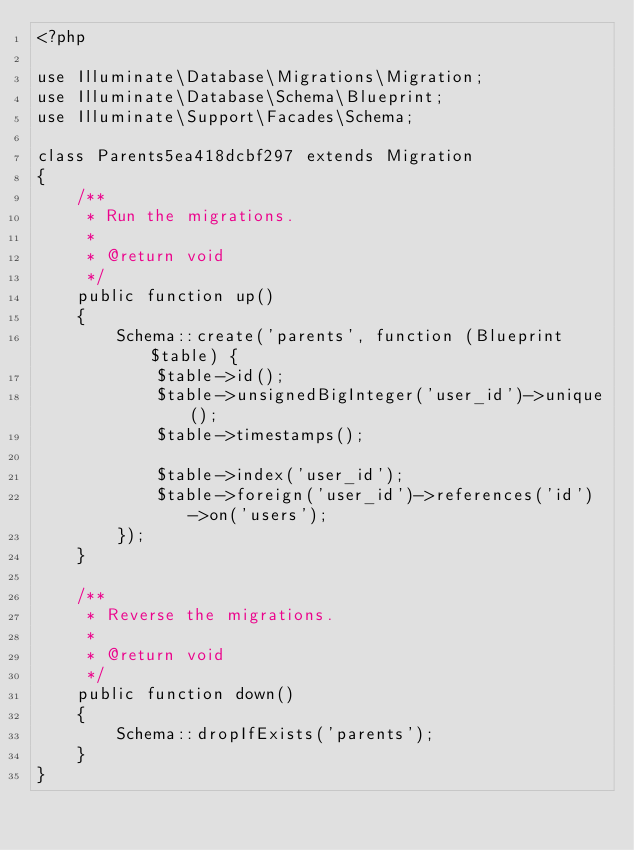<code> <loc_0><loc_0><loc_500><loc_500><_PHP_><?php

use Illuminate\Database\Migrations\Migration;
use Illuminate\Database\Schema\Blueprint;
use Illuminate\Support\Facades\Schema;

class Parents5ea418dcbf297 extends Migration
{
    /**
     * Run the migrations.
     *
     * @return void
     */
    public function up()
    {
        Schema::create('parents', function (Blueprint $table) {
            $table->id();
            $table->unsignedBigInteger('user_id')->unique();
            $table->timestamps();

            $table->index('user_id');
            $table->foreign('user_id')->references('id')->on('users');
        });
    }

    /**
     * Reverse the migrations.
     *
     * @return void
     */
    public function down()
    {
        Schema::dropIfExists('parents');
    }
}
</code> 